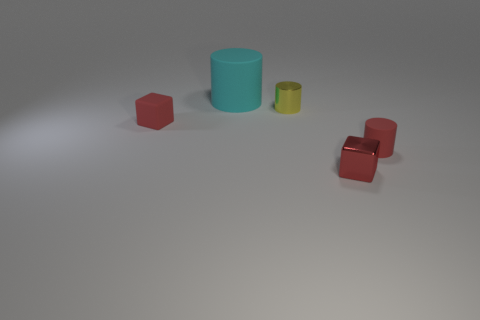Is there anything else that has the same size as the cyan matte cylinder?
Give a very brief answer. No. Does the rubber block have the same color as the matte cylinder that is to the right of the big cylinder?
Your answer should be very brief. Yes. Is the number of tiny red rubber objects that are behind the red cylinder less than the number of matte cubes?
Offer a terse response. No. What number of other things are there of the same size as the shiny cylinder?
Offer a terse response. 3. Does the red matte thing that is to the right of the yellow cylinder have the same shape as the tiny yellow metal object?
Your answer should be very brief. Yes. Are there more tiny rubber cylinders behind the large cylinder than metallic things?
Provide a short and direct response. No. The thing that is in front of the cyan object and left of the yellow object is made of what material?
Ensure brevity in your answer.  Rubber. Is there any other thing that is the same shape as the big cyan matte thing?
Make the answer very short. Yes. How many objects are both in front of the tiny shiny cylinder and on the left side of the small red metallic block?
Give a very brief answer. 1. What is the material of the yellow cylinder?
Ensure brevity in your answer.  Metal. 